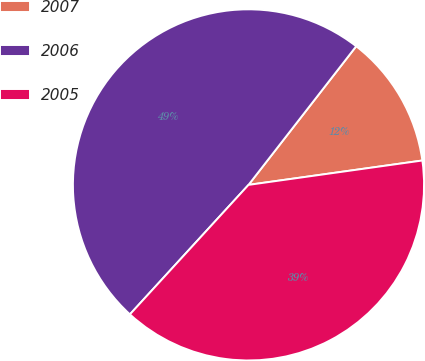Convert chart. <chart><loc_0><loc_0><loc_500><loc_500><pie_chart><fcel>2007<fcel>2006<fcel>2005<nl><fcel>12.27%<fcel>48.71%<fcel>39.02%<nl></chart> 